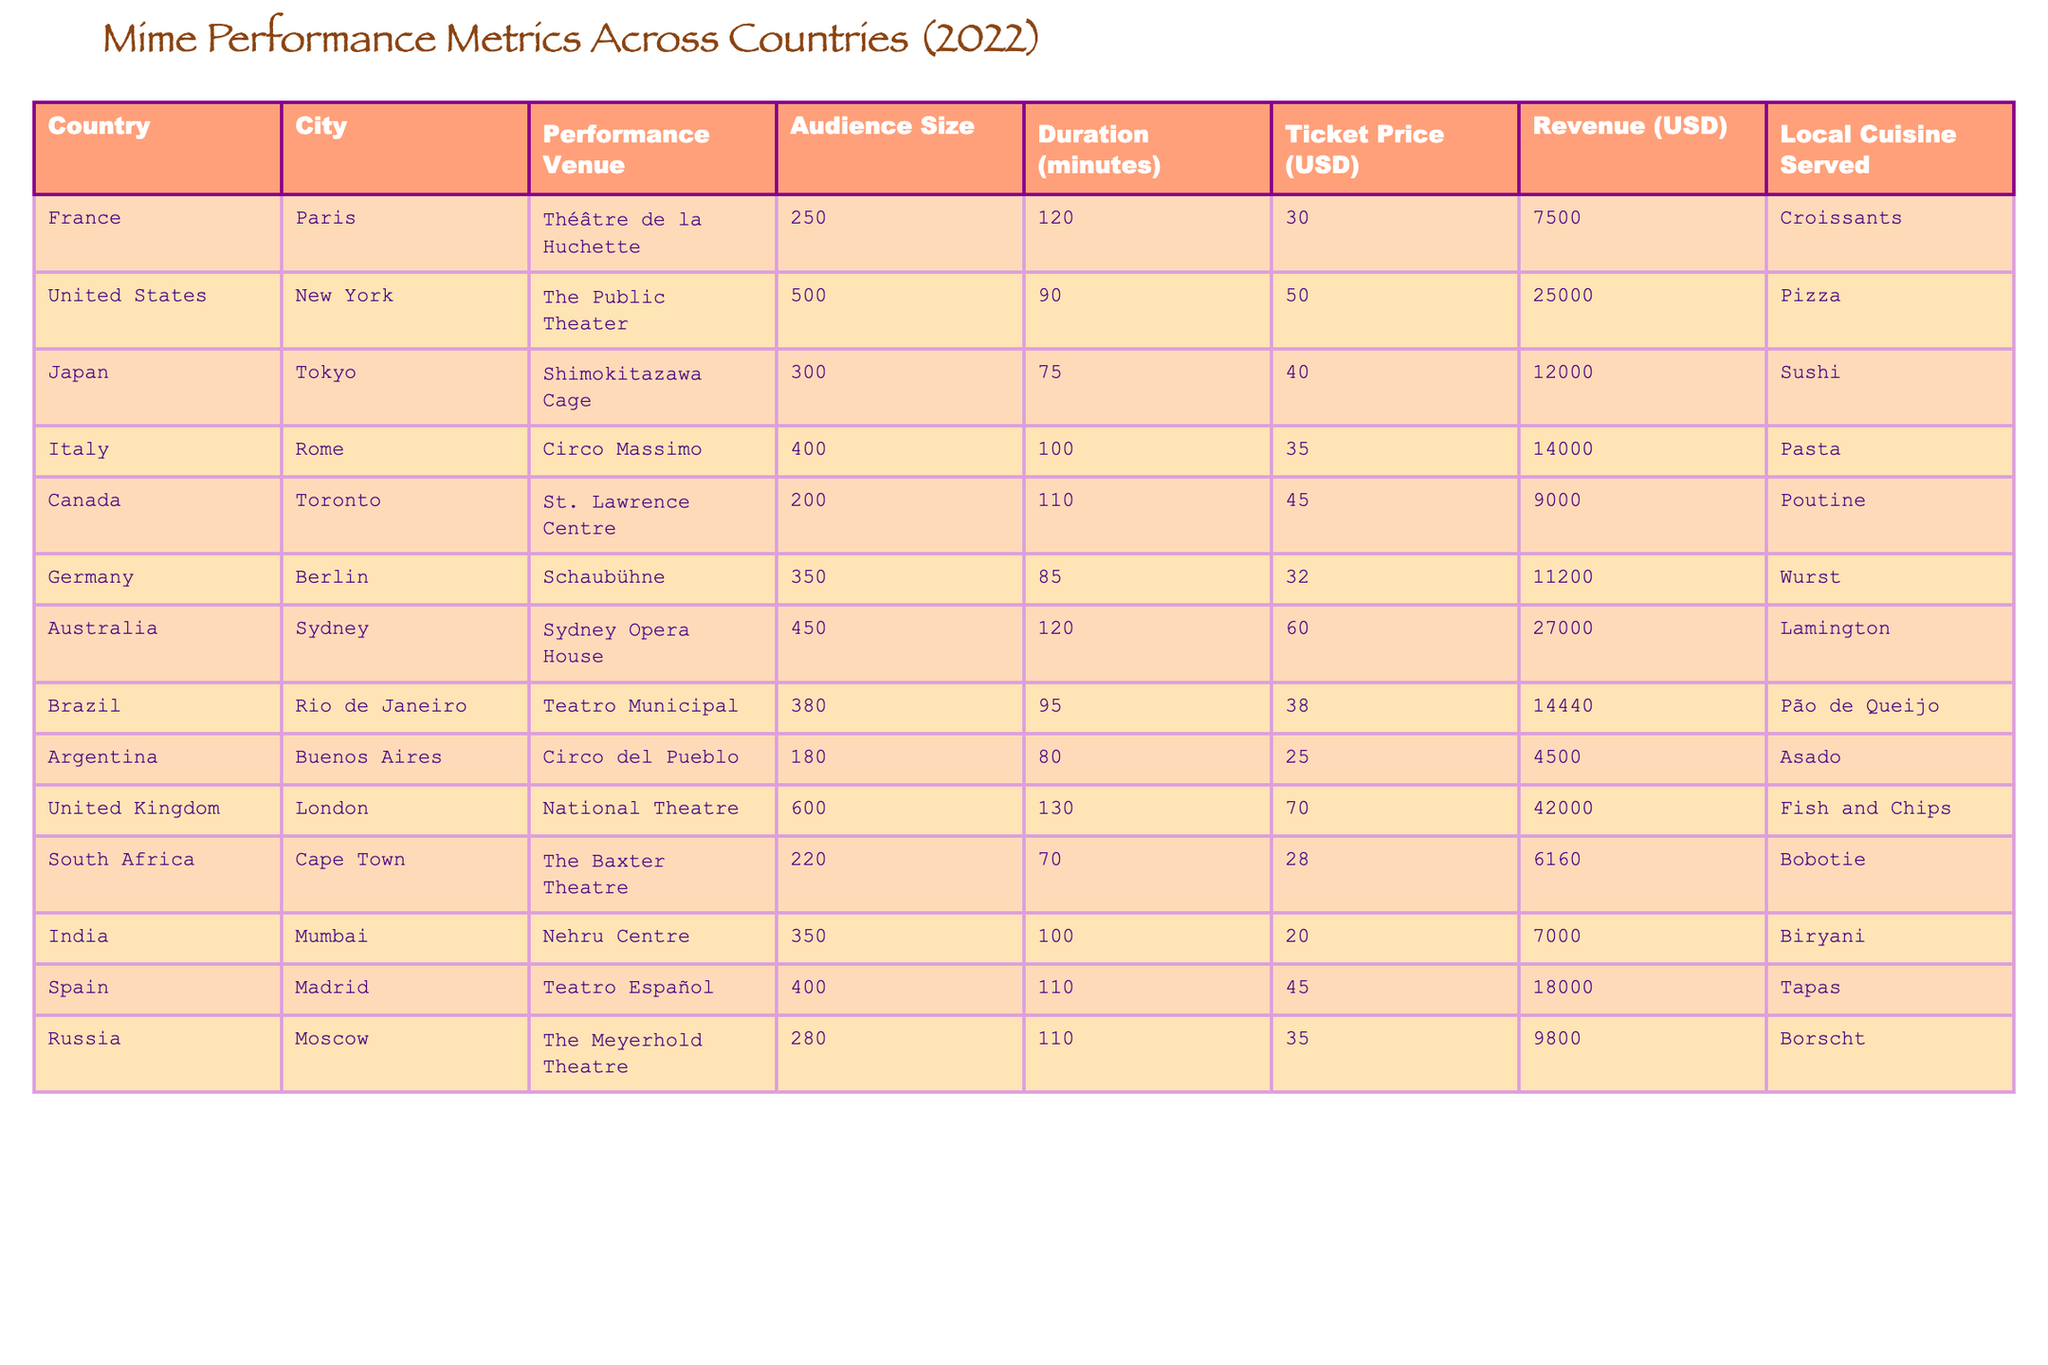What is the audience size at the National Theatre in London? From the table, the audience size is explicitly listed under the column "Audience Size." For London, it states a size of 600.
Answer: 600 What was the ticket price for a performance in Rio de Janeiro? Referring to the table, we can find the "Ticket Price" column for Rio de Janeiro, which shows a price of 38 USD.
Answer: 38 USD Which country had the highest revenue from mime shows? By examining the "Revenue" column, we can compare all the values. The highest revenue is listed as 42,000 USD for the United Kingdom.
Answer: United Kingdom What is the average audience size of the performances listed? To find the average, sum up all audience sizes (250 + 500 + 300 + 400 + 200 + 350 + 450 + 380 + 180 + 600 + 220 + 350 + 400 + 280) which totals 4,020, then divide by the number of performances (14). The average audience size is 4,020/14 ≈ 287.14.
Answer: Approximately 287 Did any performance in Canada have a ticket price below 30 USD? Looking at the "Ticket Price" column, we see that the lowest ticket price in Canada is 45 USD, meaning there wasn't any performance for less than 30 USD.
Answer: No What is the difference in ticket price between the performance in Australia and the performance in Argentina? The ticket price for Australia is 60 USD and for Argentina is 25 USD. The difference is calculated as 60 - 25 = 35 USD.
Answer: 35 USD Which venue had the longest performance duration and what was that duration? By checking the "Duration (minutes)" column, we identify that the longest performance duration is 130 minutes at the National Theatre in London.
Answer: 130 minutes How many performances had an audience size greater than 300? Reviewing the "Audience Size" column, we identify performances with sizes greater than 300: New York (500), Tokyo (300), Rome (400), Berlin (350), Sydney (450), and London (600) which sums to 6 total performances.
Answer: 6 Which local cuisine was served at the performance venue in Japan? The "Local Cuisine Served" column indicates that the cuisine served in Japan was Sushi during the performance in Tokyo.
Answer: Sushi What was the total revenue generated from performances in European countries (France, Germany, Italy, Spain, and United Kingdom)? By summing the revenues from the respective countries: France (7500) + Germany (11200) + Italy (14000) + Spain (18000) + United Kingdom (42000) equals 92700 USD.
Answer: 92,700 USD 